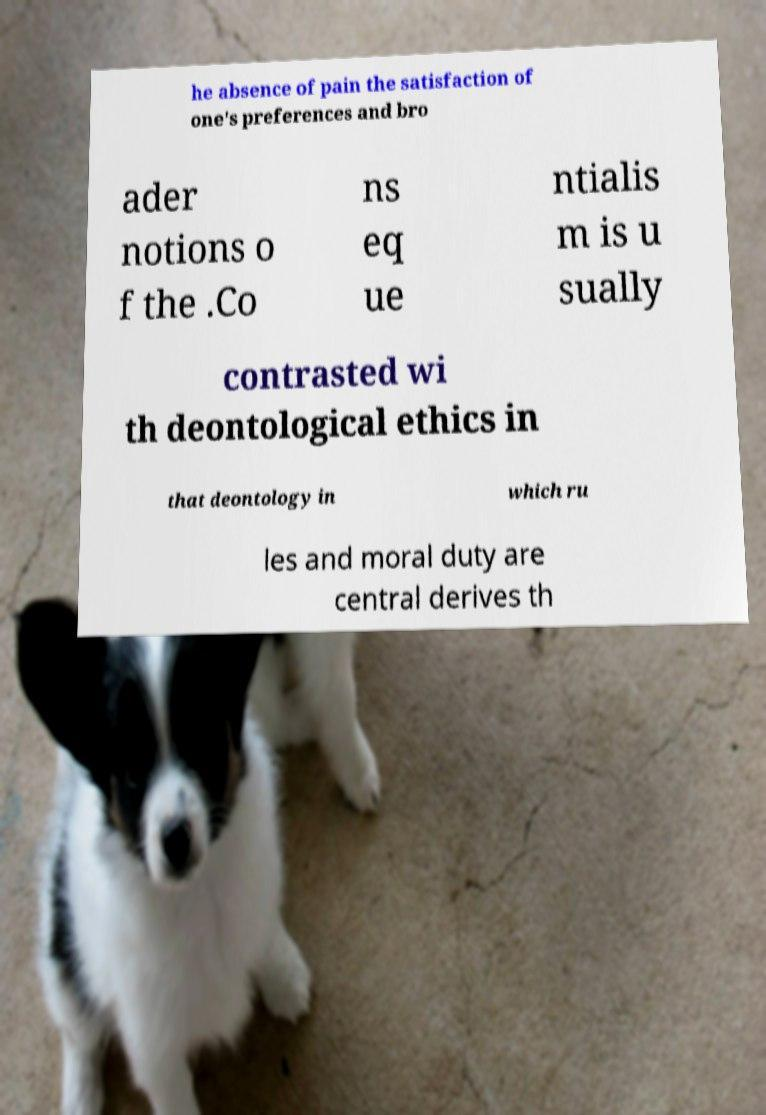For documentation purposes, I need the text within this image transcribed. Could you provide that? he absence of pain the satisfaction of one's preferences and bro ader notions o f the .Co ns eq ue ntialis m is u sually contrasted wi th deontological ethics in that deontology in which ru les and moral duty are central derives th 